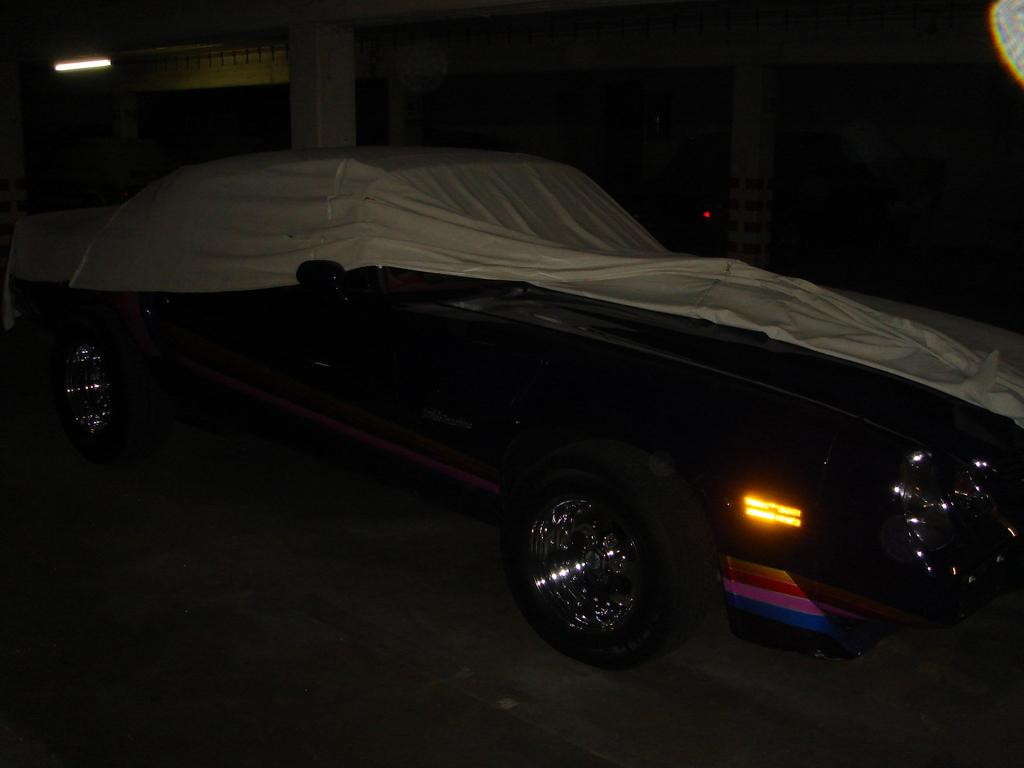What is the main object in the image? There is a car in the image. What is covering the car? The car has a cover on it. Where is the car cover located? The car cover is on the floor. What can be seen behind the car? There are pillars and a light behind the car. How many hands are visible in the image? There are no hands visible in the image. Is there a water fountain in the image? There is no water fountain present in the image. 